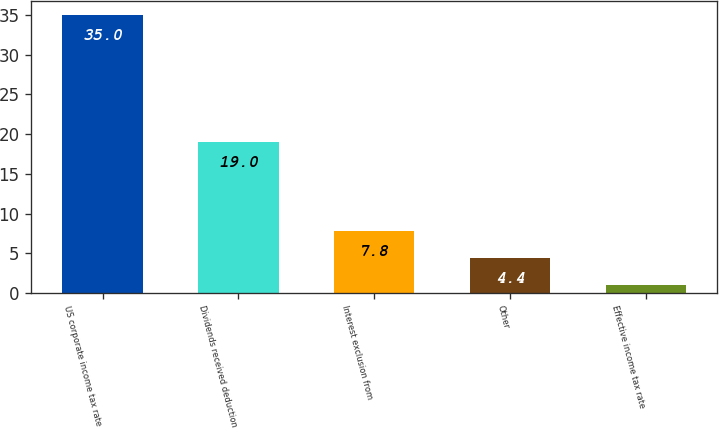<chart> <loc_0><loc_0><loc_500><loc_500><bar_chart><fcel>US corporate income tax rate<fcel>Dividends received deduction<fcel>Interest exclusion from<fcel>Other<fcel>Effective income tax rate<nl><fcel>35<fcel>19<fcel>7.8<fcel>4.4<fcel>1<nl></chart> 